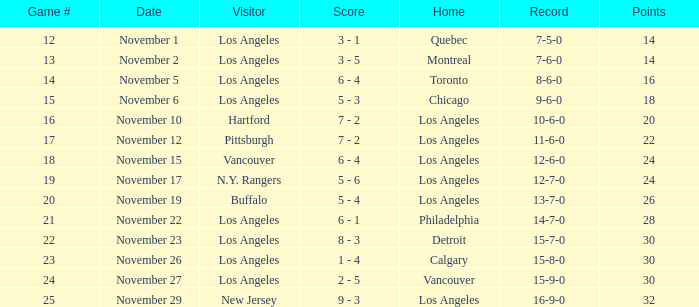What is the record of the game on November 22? 14-7-0. 